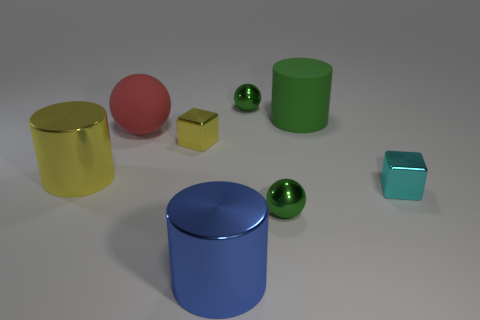There is a tiny thing that is behind the large rubber cylinder; does it have the same color as the matte sphere?
Offer a terse response. No. There is a large blue thing that is the same shape as the big green object; what material is it?
Make the answer very short. Metal. What number of green rubber things have the same size as the yellow metallic cylinder?
Give a very brief answer. 1. What is the shape of the big green rubber thing?
Provide a succinct answer. Cylinder. There is a cylinder that is both in front of the green matte cylinder and behind the big blue cylinder; how big is it?
Provide a succinct answer. Large. There is a block that is behind the cyan block; what is its material?
Your answer should be very brief. Metal. Is the color of the matte cylinder the same as the shiny thing that is on the left side of the big red object?
Give a very brief answer. No. What number of things are either tiny cubes to the right of the small yellow metal block or small cubes right of the big blue shiny cylinder?
Your response must be concise. 1. What is the color of the big cylinder that is both behind the small cyan block and left of the large green cylinder?
Provide a short and direct response. Yellow. Is the number of tiny shiny balls greater than the number of small yellow shiny things?
Provide a succinct answer. Yes. 